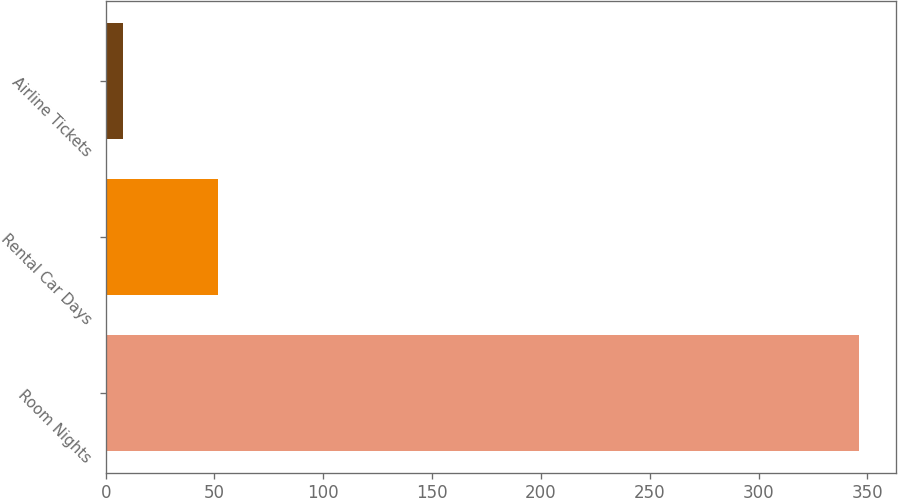<chart> <loc_0><loc_0><loc_500><loc_500><bar_chart><fcel>Room Nights<fcel>Rental Car Days<fcel>Airline Tickets<nl><fcel>346<fcel>51.8<fcel>7.8<nl></chart> 